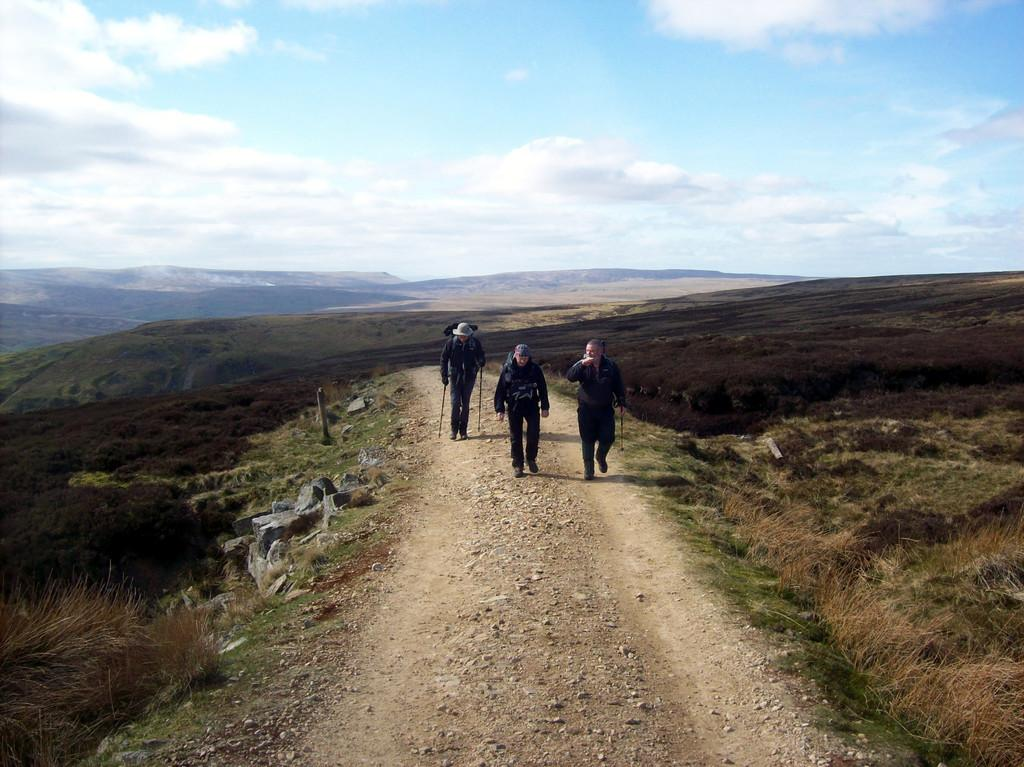How many people are walking in the image? There are three people walking in the image. What are two of the people holding? Two of the people are holding sticks. What type of terrain can be seen in the image? There are stones and grass visible in the image. What is visible in the background of the image? There are mountains and the sky visible in the background of the image. Are there any chickens present in the image? There are no chickens visible in the image. What type of food is the cook preparing in the image? There is no cook present in the image, so it cannot be determined what, if any, food they might be preparing. 